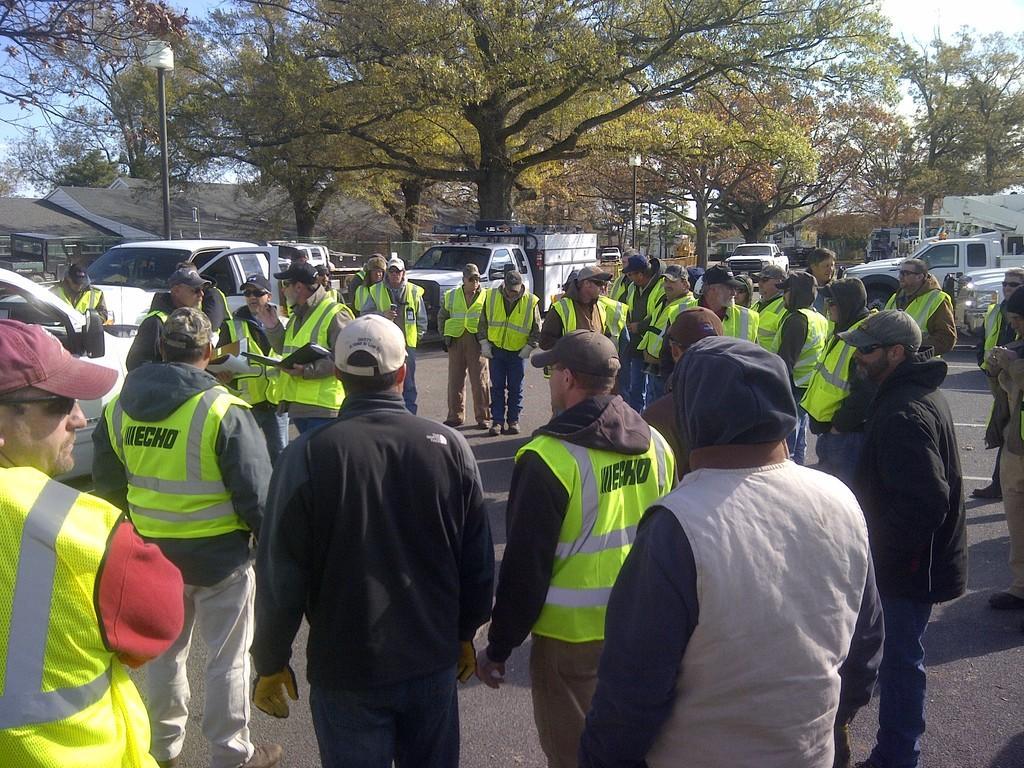Could you give a brief overview of what you see in this image? In the foreground of the picture we can see people, cars and other objects. In the middle of the picture there are trees, buildings, street light and other objects. At the top there is sky. 